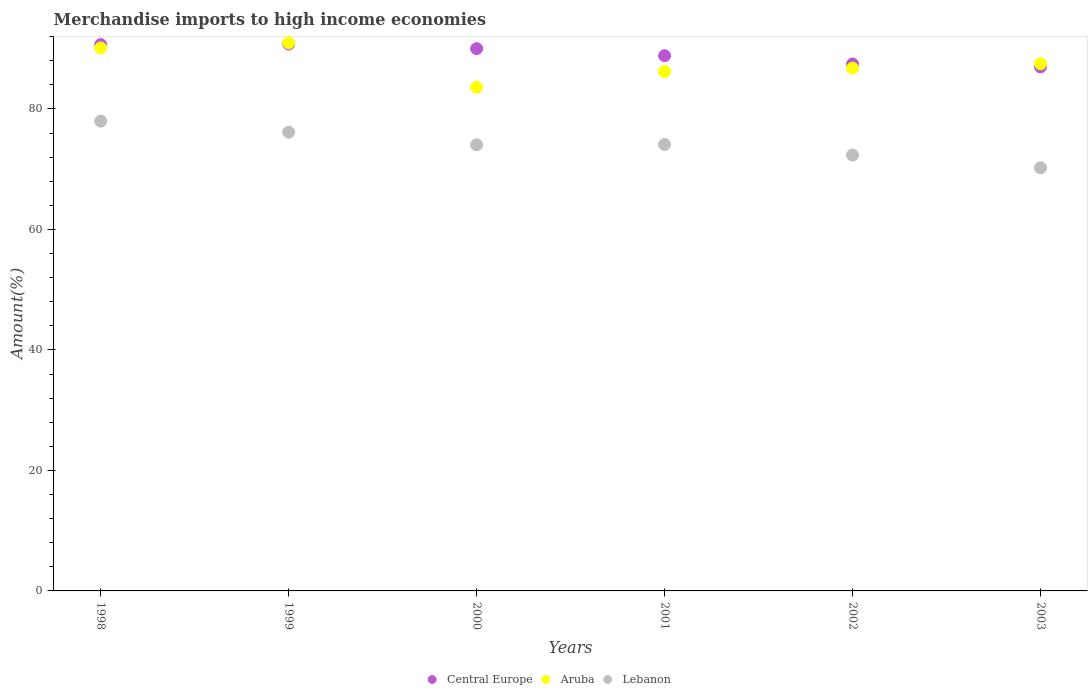Is the number of dotlines equal to the number of legend labels?
Keep it short and to the point. Yes. What is the percentage of amount earned from merchandise imports in Central Europe in 2002?
Provide a succinct answer. 87.47. Across all years, what is the maximum percentage of amount earned from merchandise imports in Aruba?
Your answer should be compact. 90.98. Across all years, what is the minimum percentage of amount earned from merchandise imports in Lebanon?
Keep it short and to the point. 70.24. What is the total percentage of amount earned from merchandise imports in Central Europe in the graph?
Give a very brief answer. 534.81. What is the difference between the percentage of amount earned from merchandise imports in Aruba in 2000 and that in 2003?
Your response must be concise. -3.9. What is the difference between the percentage of amount earned from merchandise imports in Lebanon in 2002 and the percentage of amount earned from merchandise imports in Aruba in 2000?
Provide a succinct answer. -11.26. What is the average percentage of amount earned from merchandise imports in Central Europe per year?
Ensure brevity in your answer.  89.13. In the year 1998, what is the difference between the percentage of amount earned from merchandise imports in Aruba and percentage of amount earned from merchandise imports in Central Europe?
Your response must be concise. -0.56. What is the ratio of the percentage of amount earned from merchandise imports in Aruba in 1998 to that in 2003?
Keep it short and to the point. 1.03. Is the difference between the percentage of amount earned from merchandise imports in Aruba in 1998 and 2003 greater than the difference between the percentage of amount earned from merchandise imports in Central Europe in 1998 and 2003?
Keep it short and to the point. No. What is the difference between the highest and the second highest percentage of amount earned from merchandise imports in Lebanon?
Offer a terse response. 1.84. What is the difference between the highest and the lowest percentage of amount earned from merchandise imports in Lebanon?
Your response must be concise. 7.75. Does the percentage of amount earned from merchandise imports in Aruba monotonically increase over the years?
Your answer should be compact. No. Is the percentage of amount earned from merchandise imports in Aruba strictly greater than the percentage of amount earned from merchandise imports in Lebanon over the years?
Keep it short and to the point. Yes. How many years are there in the graph?
Give a very brief answer. 6. What is the difference between two consecutive major ticks on the Y-axis?
Your response must be concise. 20. How many legend labels are there?
Your answer should be very brief. 3. How are the legend labels stacked?
Offer a terse response. Horizontal. What is the title of the graph?
Provide a short and direct response. Merchandise imports to high income economies. What is the label or title of the Y-axis?
Ensure brevity in your answer.  Amount(%). What is the Amount(%) of Central Europe in 1998?
Provide a succinct answer. 90.69. What is the Amount(%) in Aruba in 1998?
Provide a succinct answer. 90.14. What is the Amount(%) in Lebanon in 1998?
Ensure brevity in your answer.  77.99. What is the Amount(%) of Central Europe in 1999?
Offer a very short reply. 90.78. What is the Amount(%) of Aruba in 1999?
Offer a very short reply. 90.98. What is the Amount(%) of Lebanon in 1999?
Offer a terse response. 76.15. What is the Amount(%) in Central Europe in 2000?
Provide a succinct answer. 90.02. What is the Amount(%) in Aruba in 2000?
Make the answer very short. 83.61. What is the Amount(%) of Lebanon in 2000?
Offer a terse response. 74.06. What is the Amount(%) in Central Europe in 2001?
Offer a very short reply. 88.85. What is the Amount(%) in Aruba in 2001?
Provide a short and direct response. 86.21. What is the Amount(%) in Lebanon in 2001?
Make the answer very short. 74.11. What is the Amount(%) of Central Europe in 2002?
Your answer should be compact. 87.47. What is the Amount(%) of Aruba in 2002?
Provide a succinct answer. 86.78. What is the Amount(%) of Lebanon in 2002?
Give a very brief answer. 72.35. What is the Amount(%) of Central Europe in 2003?
Make the answer very short. 87. What is the Amount(%) of Aruba in 2003?
Make the answer very short. 87.51. What is the Amount(%) of Lebanon in 2003?
Your answer should be compact. 70.24. Across all years, what is the maximum Amount(%) in Central Europe?
Provide a succinct answer. 90.78. Across all years, what is the maximum Amount(%) in Aruba?
Your answer should be compact. 90.98. Across all years, what is the maximum Amount(%) of Lebanon?
Offer a very short reply. 77.99. Across all years, what is the minimum Amount(%) of Central Europe?
Offer a terse response. 87. Across all years, what is the minimum Amount(%) of Aruba?
Provide a succinct answer. 83.61. Across all years, what is the minimum Amount(%) in Lebanon?
Your response must be concise. 70.24. What is the total Amount(%) in Central Europe in the graph?
Give a very brief answer. 534.81. What is the total Amount(%) of Aruba in the graph?
Give a very brief answer. 525.24. What is the total Amount(%) of Lebanon in the graph?
Your response must be concise. 444.9. What is the difference between the Amount(%) of Central Europe in 1998 and that in 1999?
Ensure brevity in your answer.  -0.09. What is the difference between the Amount(%) in Aruba in 1998 and that in 1999?
Keep it short and to the point. -0.85. What is the difference between the Amount(%) of Lebanon in 1998 and that in 1999?
Make the answer very short. 1.84. What is the difference between the Amount(%) of Central Europe in 1998 and that in 2000?
Your answer should be very brief. 0.68. What is the difference between the Amount(%) in Aruba in 1998 and that in 2000?
Your response must be concise. 6.53. What is the difference between the Amount(%) in Lebanon in 1998 and that in 2000?
Your response must be concise. 3.93. What is the difference between the Amount(%) in Central Europe in 1998 and that in 2001?
Offer a very short reply. 1.85. What is the difference between the Amount(%) in Aruba in 1998 and that in 2001?
Your answer should be compact. 3.92. What is the difference between the Amount(%) of Lebanon in 1998 and that in 2001?
Provide a short and direct response. 3.88. What is the difference between the Amount(%) of Central Europe in 1998 and that in 2002?
Make the answer very short. 3.23. What is the difference between the Amount(%) of Aruba in 1998 and that in 2002?
Your answer should be very brief. 3.35. What is the difference between the Amount(%) of Lebanon in 1998 and that in 2002?
Give a very brief answer. 5.64. What is the difference between the Amount(%) of Central Europe in 1998 and that in 2003?
Keep it short and to the point. 3.7. What is the difference between the Amount(%) in Aruba in 1998 and that in 2003?
Make the answer very short. 2.62. What is the difference between the Amount(%) in Lebanon in 1998 and that in 2003?
Give a very brief answer. 7.75. What is the difference between the Amount(%) in Central Europe in 1999 and that in 2000?
Offer a very short reply. 0.77. What is the difference between the Amount(%) of Aruba in 1999 and that in 2000?
Your response must be concise. 7.37. What is the difference between the Amount(%) in Lebanon in 1999 and that in 2000?
Your answer should be very brief. 2.09. What is the difference between the Amount(%) in Central Europe in 1999 and that in 2001?
Provide a short and direct response. 1.94. What is the difference between the Amount(%) of Aruba in 1999 and that in 2001?
Your response must be concise. 4.77. What is the difference between the Amount(%) of Lebanon in 1999 and that in 2001?
Provide a short and direct response. 2.03. What is the difference between the Amount(%) in Central Europe in 1999 and that in 2002?
Ensure brevity in your answer.  3.32. What is the difference between the Amount(%) in Aruba in 1999 and that in 2002?
Your response must be concise. 4.2. What is the difference between the Amount(%) of Lebanon in 1999 and that in 2002?
Your answer should be very brief. 3.79. What is the difference between the Amount(%) of Central Europe in 1999 and that in 2003?
Provide a succinct answer. 3.79. What is the difference between the Amount(%) of Aruba in 1999 and that in 2003?
Offer a very short reply. 3.47. What is the difference between the Amount(%) of Lebanon in 1999 and that in 2003?
Ensure brevity in your answer.  5.9. What is the difference between the Amount(%) of Central Europe in 2000 and that in 2001?
Provide a succinct answer. 1.17. What is the difference between the Amount(%) in Aruba in 2000 and that in 2001?
Offer a terse response. -2.6. What is the difference between the Amount(%) of Lebanon in 2000 and that in 2001?
Your response must be concise. -0.05. What is the difference between the Amount(%) of Central Europe in 2000 and that in 2002?
Offer a terse response. 2.55. What is the difference between the Amount(%) in Aruba in 2000 and that in 2002?
Your answer should be very brief. -3.17. What is the difference between the Amount(%) of Lebanon in 2000 and that in 2002?
Ensure brevity in your answer.  1.71. What is the difference between the Amount(%) in Central Europe in 2000 and that in 2003?
Your answer should be compact. 3.02. What is the difference between the Amount(%) in Aruba in 2000 and that in 2003?
Provide a short and direct response. -3.9. What is the difference between the Amount(%) in Lebanon in 2000 and that in 2003?
Give a very brief answer. 3.82. What is the difference between the Amount(%) of Central Europe in 2001 and that in 2002?
Make the answer very short. 1.38. What is the difference between the Amount(%) of Aruba in 2001 and that in 2002?
Keep it short and to the point. -0.57. What is the difference between the Amount(%) of Lebanon in 2001 and that in 2002?
Keep it short and to the point. 1.76. What is the difference between the Amount(%) of Central Europe in 2001 and that in 2003?
Keep it short and to the point. 1.85. What is the difference between the Amount(%) in Aruba in 2001 and that in 2003?
Your answer should be compact. -1.3. What is the difference between the Amount(%) in Lebanon in 2001 and that in 2003?
Offer a terse response. 3.87. What is the difference between the Amount(%) of Central Europe in 2002 and that in 2003?
Keep it short and to the point. 0.47. What is the difference between the Amount(%) of Aruba in 2002 and that in 2003?
Make the answer very short. -0.73. What is the difference between the Amount(%) of Lebanon in 2002 and that in 2003?
Your answer should be very brief. 2.11. What is the difference between the Amount(%) of Central Europe in 1998 and the Amount(%) of Aruba in 1999?
Keep it short and to the point. -0.29. What is the difference between the Amount(%) of Central Europe in 1998 and the Amount(%) of Lebanon in 1999?
Provide a short and direct response. 14.55. What is the difference between the Amount(%) in Aruba in 1998 and the Amount(%) in Lebanon in 1999?
Provide a short and direct response. 13.99. What is the difference between the Amount(%) in Central Europe in 1998 and the Amount(%) in Aruba in 2000?
Offer a terse response. 7.08. What is the difference between the Amount(%) in Central Europe in 1998 and the Amount(%) in Lebanon in 2000?
Your answer should be very brief. 16.63. What is the difference between the Amount(%) of Aruba in 1998 and the Amount(%) of Lebanon in 2000?
Your answer should be compact. 16.08. What is the difference between the Amount(%) in Central Europe in 1998 and the Amount(%) in Aruba in 2001?
Provide a short and direct response. 4.48. What is the difference between the Amount(%) in Central Europe in 1998 and the Amount(%) in Lebanon in 2001?
Offer a terse response. 16.58. What is the difference between the Amount(%) of Aruba in 1998 and the Amount(%) of Lebanon in 2001?
Offer a very short reply. 16.02. What is the difference between the Amount(%) of Central Europe in 1998 and the Amount(%) of Aruba in 2002?
Offer a very short reply. 3.91. What is the difference between the Amount(%) in Central Europe in 1998 and the Amount(%) in Lebanon in 2002?
Your response must be concise. 18.34. What is the difference between the Amount(%) of Aruba in 1998 and the Amount(%) of Lebanon in 2002?
Your answer should be compact. 17.79. What is the difference between the Amount(%) of Central Europe in 1998 and the Amount(%) of Aruba in 2003?
Your response must be concise. 3.18. What is the difference between the Amount(%) of Central Europe in 1998 and the Amount(%) of Lebanon in 2003?
Your answer should be very brief. 20.45. What is the difference between the Amount(%) in Aruba in 1998 and the Amount(%) in Lebanon in 2003?
Provide a succinct answer. 19.89. What is the difference between the Amount(%) in Central Europe in 1999 and the Amount(%) in Aruba in 2000?
Make the answer very short. 7.17. What is the difference between the Amount(%) in Central Europe in 1999 and the Amount(%) in Lebanon in 2000?
Give a very brief answer. 16.72. What is the difference between the Amount(%) of Aruba in 1999 and the Amount(%) of Lebanon in 2000?
Keep it short and to the point. 16.92. What is the difference between the Amount(%) of Central Europe in 1999 and the Amount(%) of Aruba in 2001?
Give a very brief answer. 4.57. What is the difference between the Amount(%) of Central Europe in 1999 and the Amount(%) of Lebanon in 2001?
Provide a succinct answer. 16.67. What is the difference between the Amount(%) of Aruba in 1999 and the Amount(%) of Lebanon in 2001?
Keep it short and to the point. 16.87. What is the difference between the Amount(%) in Central Europe in 1999 and the Amount(%) in Aruba in 2002?
Ensure brevity in your answer.  4. What is the difference between the Amount(%) in Central Europe in 1999 and the Amount(%) in Lebanon in 2002?
Your response must be concise. 18.43. What is the difference between the Amount(%) of Aruba in 1999 and the Amount(%) of Lebanon in 2002?
Give a very brief answer. 18.63. What is the difference between the Amount(%) in Central Europe in 1999 and the Amount(%) in Aruba in 2003?
Offer a very short reply. 3.27. What is the difference between the Amount(%) in Central Europe in 1999 and the Amount(%) in Lebanon in 2003?
Keep it short and to the point. 20.54. What is the difference between the Amount(%) of Aruba in 1999 and the Amount(%) of Lebanon in 2003?
Provide a short and direct response. 20.74. What is the difference between the Amount(%) in Central Europe in 2000 and the Amount(%) in Aruba in 2001?
Keep it short and to the point. 3.81. What is the difference between the Amount(%) in Central Europe in 2000 and the Amount(%) in Lebanon in 2001?
Your response must be concise. 15.9. What is the difference between the Amount(%) of Aruba in 2000 and the Amount(%) of Lebanon in 2001?
Your answer should be compact. 9.5. What is the difference between the Amount(%) of Central Europe in 2000 and the Amount(%) of Aruba in 2002?
Offer a terse response. 3.24. What is the difference between the Amount(%) of Central Europe in 2000 and the Amount(%) of Lebanon in 2002?
Offer a very short reply. 17.67. What is the difference between the Amount(%) of Aruba in 2000 and the Amount(%) of Lebanon in 2002?
Provide a succinct answer. 11.26. What is the difference between the Amount(%) in Central Europe in 2000 and the Amount(%) in Aruba in 2003?
Offer a very short reply. 2.5. What is the difference between the Amount(%) in Central Europe in 2000 and the Amount(%) in Lebanon in 2003?
Your answer should be very brief. 19.77. What is the difference between the Amount(%) in Aruba in 2000 and the Amount(%) in Lebanon in 2003?
Your response must be concise. 13.37. What is the difference between the Amount(%) in Central Europe in 2001 and the Amount(%) in Aruba in 2002?
Your answer should be compact. 2.06. What is the difference between the Amount(%) in Central Europe in 2001 and the Amount(%) in Lebanon in 2002?
Your answer should be very brief. 16.5. What is the difference between the Amount(%) in Aruba in 2001 and the Amount(%) in Lebanon in 2002?
Keep it short and to the point. 13.86. What is the difference between the Amount(%) in Central Europe in 2001 and the Amount(%) in Aruba in 2003?
Offer a terse response. 1.33. What is the difference between the Amount(%) of Central Europe in 2001 and the Amount(%) of Lebanon in 2003?
Give a very brief answer. 18.6. What is the difference between the Amount(%) in Aruba in 2001 and the Amount(%) in Lebanon in 2003?
Your answer should be very brief. 15.97. What is the difference between the Amount(%) in Central Europe in 2002 and the Amount(%) in Aruba in 2003?
Offer a very short reply. -0.05. What is the difference between the Amount(%) of Central Europe in 2002 and the Amount(%) of Lebanon in 2003?
Keep it short and to the point. 17.22. What is the difference between the Amount(%) of Aruba in 2002 and the Amount(%) of Lebanon in 2003?
Offer a very short reply. 16.54. What is the average Amount(%) of Central Europe per year?
Provide a succinct answer. 89.13. What is the average Amount(%) in Aruba per year?
Your answer should be compact. 87.54. What is the average Amount(%) of Lebanon per year?
Your answer should be very brief. 74.15. In the year 1998, what is the difference between the Amount(%) in Central Europe and Amount(%) in Aruba?
Your response must be concise. 0.56. In the year 1998, what is the difference between the Amount(%) in Central Europe and Amount(%) in Lebanon?
Your response must be concise. 12.7. In the year 1998, what is the difference between the Amount(%) of Aruba and Amount(%) of Lebanon?
Make the answer very short. 12.15. In the year 1999, what is the difference between the Amount(%) in Central Europe and Amount(%) in Aruba?
Provide a short and direct response. -0.2. In the year 1999, what is the difference between the Amount(%) in Central Europe and Amount(%) in Lebanon?
Ensure brevity in your answer.  14.64. In the year 1999, what is the difference between the Amount(%) of Aruba and Amount(%) of Lebanon?
Your answer should be very brief. 14.84. In the year 2000, what is the difference between the Amount(%) in Central Europe and Amount(%) in Aruba?
Provide a succinct answer. 6.41. In the year 2000, what is the difference between the Amount(%) of Central Europe and Amount(%) of Lebanon?
Your answer should be compact. 15.96. In the year 2000, what is the difference between the Amount(%) of Aruba and Amount(%) of Lebanon?
Offer a very short reply. 9.55. In the year 2001, what is the difference between the Amount(%) of Central Europe and Amount(%) of Aruba?
Provide a short and direct response. 2.63. In the year 2001, what is the difference between the Amount(%) of Central Europe and Amount(%) of Lebanon?
Offer a terse response. 14.73. In the year 2001, what is the difference between the Amount(%) in Aruba and Amount(%) in Lebanon?
Give a very brief answer. 12.1. In the year 2002, what is the difference between the Amount(%) of Central Europe and Amount(%) of Aruba?
Ensure brevity in your answer.  0.68. In the year 2002, what is the difference between the Amount(%) in Central Europe and Amount(%) in Lebanon?
Offer a very short reply. 15.12. In the year 2002, what is the difference between the Amount(%) of Aruba and Amount(%) of Lebanon?
Offer a terse response. 14.43. In the year 2003, what is the difference between the Amount(%) in Central Europe and Amount(%) in Aruba?
Offer a terse response. -0.52. In the year 2003, what is the difference between the Amount(%) in Central Europe and Amount(%) in Lebanon?
Provide a succinct answer. 16.75. In the year 2003, what is the difference between the Amount(%) of Aruba and Amount(%) of Lebanon?
Ensure brevity in your answer.  17.27. What is the ratio of the Amount(%) of Central Europe in 1998 to that in 1999?
Your answer should be very brief. 1. What is the ratio of the Amount(%) of Lebanon in 1998 to that in 1999?
Provide a short and direct response. 1.02. What is the ratio of the Amount(%) in Central Europe in 1998 to that in 2000?
Provide a short and direct response. 1.01. What is the ratio of the Amount(%) of Aruba in 1998 to that in 2000?
Make the answer very short. 1.08. What is the ratio of the Amount(%) of Lebanon in 1998 to that in 2000?
Your response must be concise. 1.05. What is the ratio of the Amount(%) in Central Europe in 1998 to that in 2001?
Provide a short and direct response. 1.02. What is the ratio of the Amount(%) in Aruba in 1998 to that in 2001?
Give a very brief answer. 1.05. What is the ratio of the Amount(%) in Lebanon in 1998 to that in 2001?
Offer a terse response. 1.05. What is the ratio of the Amount(%) of Central Europe in 1998 to that in 2002?
Offer a terse response. 1.04. What is the ratio of the Amount(%) of Aruba in 1998 to that in 2002?
Your answer should be very brief. 1.04. What is the ratio of the Amount(%) in Lebanon in 1998 to that in 2002?
Keep it short and to the point. 1.08. What is the ratio of the Amount(%) in Central Europe in 1998 to that in 2003?
Ensure brevity in your answer.  1.04. What is the ratio of the Amount(%) in Aruba in 1998 to that in 2003?
Your answer should be compact. 1.03. What is the ratio of the Amount(%) of Lebanon in 1998 to that in 2003?
Give a very brief answer. 1.11. What is the ratio of the Amount(%) of Central Europe in 1999 to that in 2000?
Make the answer very short. 1.01. What is the ratio of the Amount(%) of Aruba in 1999 to that in 2000?
Provide a succinct answer. 1.09. What is the ratio of the Amount(%) of Lebanon in 1999 to that in 2000?
Provide a short and direct response. 1.03. What is the ratio of the Amount(%) of Central Europe in 1999 to that in 2001?
Ensure brevity in your answer.  1.02. What is the ratio of the Amount(%) in Aruba in 1999 to that in 2001?
Your response must be concise. 1.06. What is the ratio of the Amount(%) in Lebanon in 1999 to that in 2001?
Provide a short and direct response. 1.03. What is the ratio of the Amount(%) of Central Europe in 1999 to that in 2002?
Offer a terse response. 1.04. What is the ratio of the Amount(%) of Aruba in 1999 to that in 2002?
Your answer should be compact. 1.05. What is the ratio of the Amount(%) in Lebanon in 1999 to that in 2002?
Ensure brevity in your answer.  1.05. What is the ratio of the Amount(%) of Central Europe in 1999 to that in 2003?
Offer a terse response. 1.04. What is the ratio of the Amount(%) in Aruba in 1999 to that in 2003?
Offer a terse response. 1.04. What is the ratio of the Amount(%) of Lebanon in 1999 to that in 2003?
Offer a very short reply. 1.08. What is the ratio of the Amount(%) of Central Europe in 2000 to that in 2001?
Offer a very short reply. 1.01. What is the ratio of the Amount(%) of Aruba in 2000 to that in 2001?
Your response must be concise. 0.97. What is the ratio of the Amount(%) of Central Europe in 2000 to that in 2002?
Your response must be concise. 1.03. What is the ratio of the Amount(%) of Aruba in 2000 to that in 2002?
Your answer should be compact. 0.96. What is the ratio of the Amount(%) in Lebanon in 2000 to that in 2002?
Your response must be concise. 1.02. What is the ratio of the Amount(%) in Central Europe in 2000 to that in 2003?
Provide a succinct answer. 1.03. What is the ratio of the Amount(%) of Aruba in 2000 to that in 2003?
Your answer should be very brief. 0.96. What is the ratio of the Amount(%) in Lebanon in 2000 to that in 2003?
Your response must be concise. 1.05. What is the ratio of the Amount(%) of Central Europe in 2001 to that in 2002?
Provide a succinct answer. 1.02. What is the ratio of the Amount(%) of Lebanon in 2001 to that in 2002?
Provide a short and direct response. 1.02. What is the ratio of the Amount(%) of Central Europe in 2001 to that in 2003?
Provide a short and direct response. 1.02. What is the ratio of the Amount(%) in Aruba in 2001 to that in 2003?
Your answer should be very brief. 0.99. What is the ratio of the Amount(%) in Lebanon in 2001 to that in 2003?
Your answer should be compact. 1.06. What is the ratio of the Amount(%) in Central Europe in 2002 to that in 2003?
Provide a succinct answer. 1.01. What is the ratio of the Amount(%) of Aruba in 2002 to that in 2003?
Provide a short and direct response. 0.99. What is the difference between the highest and the second highest Amount(%) in Central Europe?
Your answer should be very brief. 0.09. What is the difference between the highest and the second highest Amount(%) in Aruba?
Give a very brief answer. 0.85. What is the difference between the highest and the second highest Amount(%) of Lebanon?
Your answer should be compact. 1.84. What is the difference between the highest and the lowest Amount(%) in Central Europe?
Give a very brief answer. 3.79. What is the difference between the highest and the lowest Amount(%) in Aruba?
Ensure brevity in your answer.  7.37. What is the difference between the highest and the lowest Amount(%) of Lebanon?
Your answer should be very brief. 7.75. 